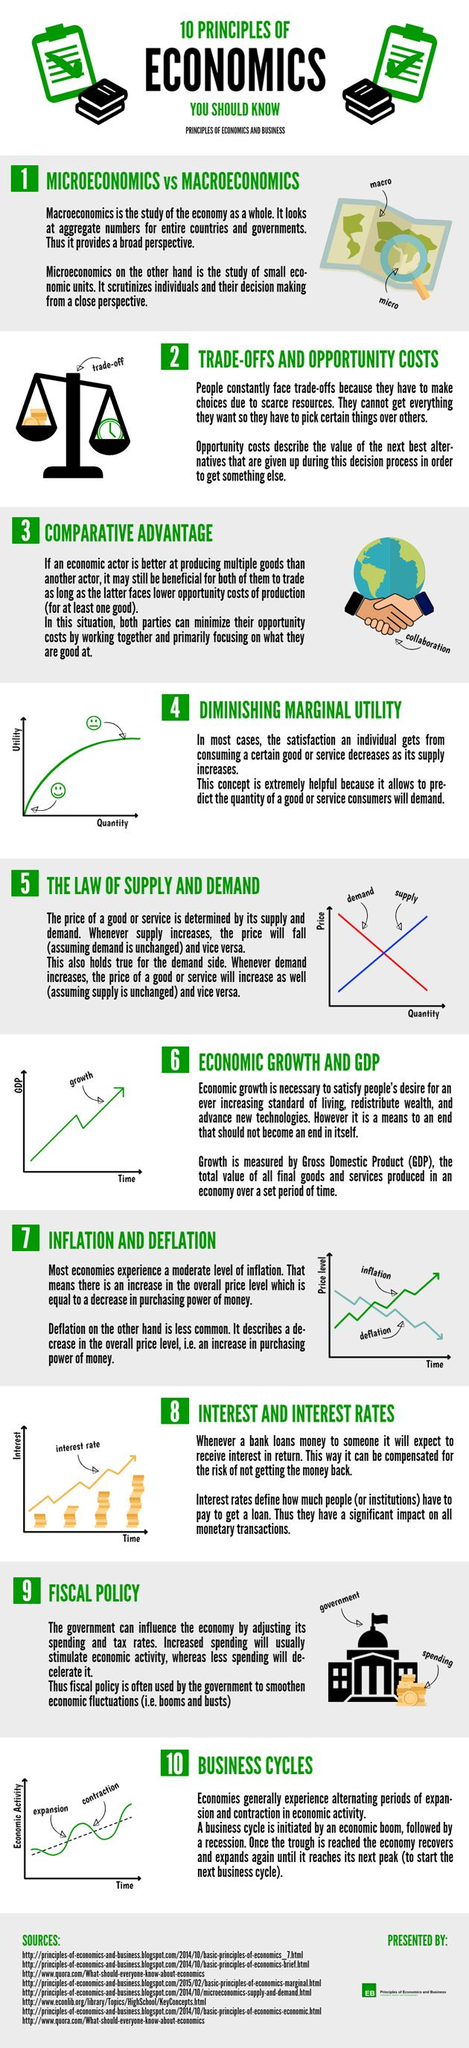Highlight a few significant elements in this photo. There are a total of 8 sources listed. The quantity of a good or service that consumers are willing to demand is predicted by diminishing marginal utility. Inflation is more common than deflation. The color of the demand line in the graph is red. 